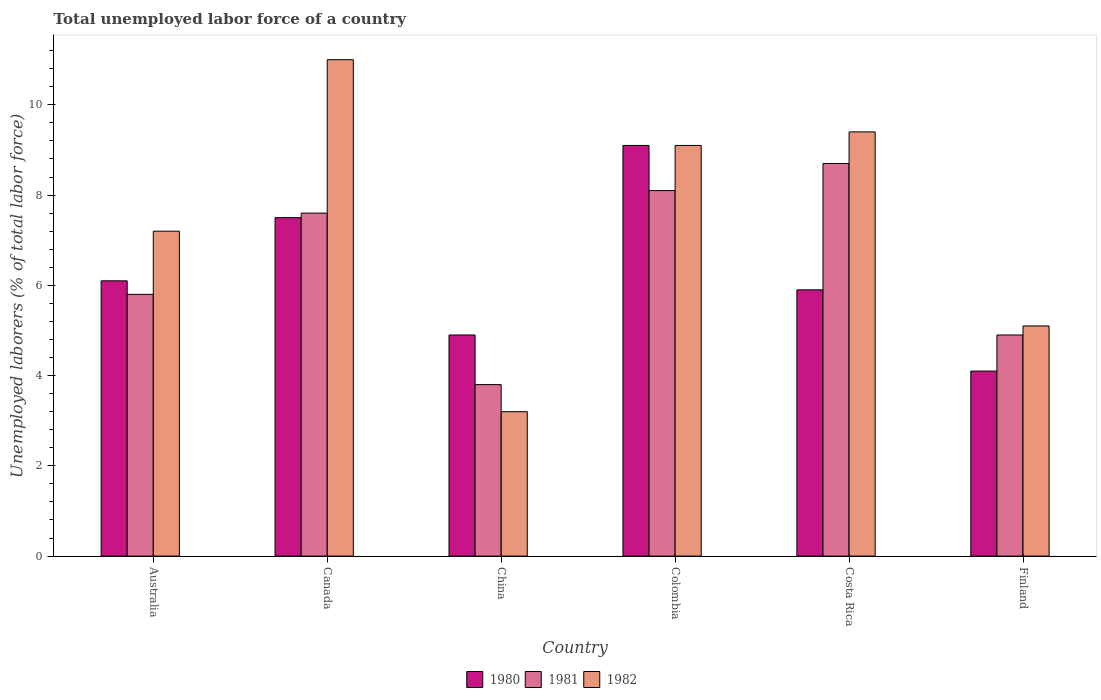How many different coloured bars are there?
Ensure brevity in your answer.  3. How many groups of bars are there?
Your answer should be compact. 6. Are the number of bars on each tick of the X-axis equal?
Provide a succinct answer. Yes. How many bars are there on the 2nd tick from the left?
Offer a terse response. 3. In how many cases, is the number of bars for a given country not equal to the number of legend labels?
Make the answer very short. 0. What is the total unemployed labor force in 1981 in Australia?
Give a very brief answer. 5.8. Across all countries, what is the maximum total unemployed labor force in 1980?
Your answer should be compact. 9.1. Across all countries, what is the minimum total unemployed labor force in 1981?
Your answer should be compact. 3.8. What is the total total unemployed labor force in 1980 in the graph?
Your answer should be very brief. 37.6. What is the difference between the total unemployed labor force in 1980 in China and that in Finland?
Your answer should be compact. 0.8. What is the difference between the total unemployed labor force in 1982 in Colombia and the total unemployed labor force in 1981 in China?
Give a very brief answer. 5.3. What is the average total unemployed labor force in 1980 per country?
Offer a very short reply. 6.27. In how many countries, is the total unemployed labor force in 1981 greater than 2.4 %?
Keep it short and to the point. 6. What is the ratio of the total unemployed labor force in 1980 in Canada to that in Colombia?
Make the answer very short. 0.82. Is the total unemployed labor force in 1980 in China less than that in Colombia?
Offer a very short reply. Yes. What is the difference between the highest and the second highest total unemployed labor force in 1981?
Ensure brevity in your answer.  0.6. What is the difference between the highest and the lowest total unemployed labor force in 1982?
Ensure brevity in your answer.  7.8. In how many countries, is the total unemployed labor force in 1982 greater than the average total unemployed labor force in 1982 taken over all countries?
Your response must be concise. 3. Is it the case that in every country, the sum of the total unemployed labor force in 1981 and total unemployed labor force in 1982 is greater than the total unemployed labor force in 1980?
Keep it short and to the point. Yes. How many countries are there in the graph?
Give a very brief answer. 6. Are the values on the major ticks of Y-axis written in scientific E-notation?
Your response must be concise. No. Does the graph contain grids?
Your answer should be very brief. No. What is the title of the graph?
Give a very brief answer. Total unemployed labor force of a country. What is the label or title of the Y-axis?
Provide a succinct answer. Unemployed laborers (% of total labor force). What is the Unemployed laborers (% of total labor force) of 1980 in Australia?
Your answer should be very brief. 6.1. What is the Unemployed laborers (% of total labor force) in 1981 in Australia?
Make the answer very short. 5.8. What is the Unemployed laborers (% of total labor force) in 1982 in Australia?
Your answer should be very brief. 7.2. What is the Unemployed laborers (% of total labor force) in 1981 in Canada?
Offer a very short reply. 7.6. What is the Unemployed laborers (% of total labor force) of 1982 in Canada?
Give a very brief answer. 11. What is the Unemployed laborers (% of total labor force) of 1980 in China?
Provide a succinct answer. 4.9. What is the Unemployed laborers (% of total labor force) of 1981 in China?
Your response must be concise. 3.8. What is the Unemployed laborers (% of total labor force) in 1982 in China?
Provide a succinct answer. 3.2. What is the Unemployed laborers (% of total labor force) of 1980 in Colombia?
Your answer should be very brief. 9.1. What is the Unemployed laborers (% of total labor force) of 1981 in Colombia?
Offer a very short reply. 8.1. What is the Unemployed laborers (% of total labor force) of 1982 in Colombia?
Provide a short and direct response. 9.1. What is the Unemployed laborers (% of total labor force) in 1980 in Costa Rica?
Provide a short and direct response. 5.9. What is the Unemployed laborers (% of total labor force) of 1981 in Costa Rica?
Your answer should be very brief. 8.7. What is the Unemployed laborers (% of total labor force) in 1982 in Costa Rica?
Your response must be concise. 9.4. What is the Unemployed laborers (% of total labor force) in 1980 in Finland?
Give a very brief answer. 4.1. What is the Unemployed laborers (% of total labor force) of 1981 in Finland?
Your answer should be very brief. 4.9. What is the Unemployed laborers (% of total labor force) of 1982 in Finland?
Make the answer very short. 5.1. Across all countries, what is the maximum Unemployed laborers (% of total labor force) in 1980?
Offer a terse response. 9.1. Across all countries, what is the maximum Unemployed laborers (% of total labor force) in 1981?
Your answer should be compact. 8.7. Across all countries, what is the minimum Unemployed laborers (% of total labor force) in 1980?
Make the answer very short. 4.1. Across all countries, what is the minimum Unemployed laborers (% of total labor force) in 1981?
Keep it short and to the point. 3.8. Across all countries, what is the minimum Unemployed laborers (% of total labor force) of 1982?
Your answer should be compact. 3.2. What is the total Unemployed laborers (% of total labor force) of 1980 in the graph?
Ensure brevity in your answer.  37.6. What is the total Unemployed laborers (% of total labor force) in 1981 in the graph?
Keep it short and to the point. 38.9. What is the difference between the Unemployed laborers (% of total labor force) in 1981 in Australia and that in Canada?
Offer a very short reply. -1.8. What is the difference between the Unemployed laborers (% of total labor force) in 1982 in Australia and that in Canada?
Offer a terse response. -3.8. What is the difference between the Unemployed laborers (% of total labor force) of 1980 in Australia and that in China?
Offer a terse response. 1.2. What is the difference between the Unemployed laborers (% of total labor force) of 1980 in Australia and that in Colombia?
Make the answer very short. -3. What is the difference between the Unemployed laborers (% of total labor force) in 1980 in Australia and that in Costa Rica?
Your response must be concise. 0.2. What is the difference between the Unemployed laborers (% of total labor force) of 1980 in Australia and that in Finland?
Offer a very short reply. 2. What is the difference between the Unemployed laborers (% of total labor force) of 1980 in Canada and that in China?
Keep it short and to the point. 2.6. What is the difference between the Unemployed laborers (% of total labor force) in 1980 in Canada and that in Colombia?
Provide a short and direct response. -1.6. What is the difference between the Unemployed laborers (% of total labor force) in 1981 in Canada and that in Colombia?
Your answer should be very brief. -0.5. What is the difference between the Unemployed laborers (% of total labor force) of 1982 in Canada and that in Colombia?
Give a very brief answer. 1.9. What is the difference between the Unemployed laborers (% of total labor force) of 1981 in Canada and that in Costa Rica?
Your response must be concise. -1.1. What is the difference between the Unemployed laborers (% of total labor force) in 1980 in Canada and that in Finland?
Offer a terse response. 3.4. What is the difference between the Unemployed laborers (% of total labor force) in 1981 in Canada and that in Finland?
Ensure brevity in your answer.  2.7. What is the difference between the Unemployed laborers (% of total labor force) in 1982 in Canada and that in Finland?
Your answer should be very brief. 5.9. What is the difference between the Unemployed laborers (% of total labor force) in 1981 in China and that in Colombia?
Give a very brief answer. -4.3. What is the difference between the Unemployed laborers (% of total labor force) in 1980 in China and that in Costa Rica?
Offer a very short reply. -1. What is the difference between the Unemployed laborers (% of total labor force) of 1981 in China and that in Costa Rica?
Give a very brief answer. -4.9. What is the difference between the Unemployed laborers (% of total labor force) of 1982 in China and that in Costa Rica?
Your answer should be compact. -6.2. What is the difference between the Unemployed laborers (% of total labor force) in 1980 in Colombia and that in Costa Rica?
Provide a succinct answer. 3.2. What is the difference between the Unemployed laborers (% of total labor force) in 1981 in Colombia and that in Costa Rica?
Provide a succinct answer. -0.6. What is the difference between the Unemployed laborers (% of total labor force) of 1980 in Colombia and that in Finland?
Your response must be concise. 5. What is the difference between the Unemployed laborers (% of total labor force) of 1982 in Colombia and that in Finland?
Ensure brevity in your answer.  4. What is the difference between the Unemployed laborers (% of total labor force) in 1980 in Costa Rica and that in Finland?
Your answer should be very brief. 1.8. What is the difference between the Unemployed laborers (% of total labor force) of 1982 in Costa Rica and that in Finland?
Offer a very short reply. 4.3. What is the difference between the Unemployed laborers (% of total labor force) of 1980 in Australia and the Unemployed laborers (% of total labor force) of 1982 in Canada?
Give a very brief answer. -4.9. What is the difference between the Unemployed laborers (% of total labor force) in 1980 in Australia and the Unemployed laborers (% of total labor force) in 1981 in China?
Ensure brevity in your answer.  2.3. What is the difference between the Unemployed laborers (% of total labor force) of 1980 in Australia and the Unemployed laborers (% of total labor force) of 1982 in China?
Offer a terse response. 2.9. What is the difference between the Unemployed laborers (% of total labor force) of 1981 in Australia and the Unemployed laborers (% of total labor force) of 1982 in China?
Your answer should be compact. 2.6. What is the difference between the Unemployed laborers (% of total labor force) of 1980 in Australia and the Unemployed laborers (% of total labor force) of 1981 in Costa Rica?
Make the answer very short. -2.6. What is the difference between the Unemployed laborers (% of total labor force) of 1980 in Australia and the Unemployed laborers (% of total labor force) of 1981 in Finland?
Give a very brief answer. 1.2. What is the difference between the Unemployed laborers (% of total labor force) in 1980 in Australia and the Unemployed laborers (% of total labor force) in 1982 in Finland?
Keep it short and to the point. 1. What is the difference between the Unemployed laborers (% of total labor force) in 1981 in Australia and the Unemployed laborers (% of total labor force) in 1982 in Finland?
Ensure brevity in your answer.  0.7. What is the difference between the Unemployed laborers (% of total labor force) in 1980 in Canada and the Unemployed laborers (% of total labor force) in 1981 in China?
Offer a terse response. 3.7. What is the difference between the Unemployed laborers (% of total labor force) in 1980 in Canada and the Unemployed laborers (% of total labor force) in 1982 in China?
Provide a succinct answer. 4.3. What is the difference between the Unemployed laborers (% of total labor force) in 1980 in Canada and the Unemployed laborers (% of total labor force) in 1981 in Colombia?
Keep it short and to the point. -0.6. What is the difference between the Unemployed laborers (% of total labor force) of 1980 in Canada and the Unemployed laborers (% of total labor force) of 1982 in Colombia?
Your answer should be compact. -1.6. What is the difference between the Unemployed laborers (% of total labor force) of 1980 in Canada and the Unemployed laborers (% of total labor force) of 1982 in Costa Rica?
Make the answer very short. -1.9. What is the difference between the Unemployed laborers (% of total labor force) of 1980 in Canada and the Unemployed laborers (% of total labor force) of 1982 in Finland?
Provide a succinct answer. 2.4. What is the difference between the Unemployed laborers (% of total labor force) in 1980 in China and the Unemployed laborers (% of total labor force) in 1981 in Colombia?
Your answer should be very brief. -3.2. What is the difference between the Unemployed laborers (% of total labor force) in 1980 in China and the Unemployed laborers (% of total labor force) in 1982 in Colombia?
Your response must be concise. -4.2. What is the difference between the Unemployed laborers (% of total labor force) of 1981 in China and the Unemployed laborers (% of total labor force) of 1982 in Colombia?
Your answer should be compact. -5.3. What is the difference between the Unemployed laborers (% of total labor force) in 1980 in China and the Unemployed laborers (% of total labor force) in 1981 in Costa Rica?
Your answer should be very brief. -3.8. What is the difference between the Unemployed laborers (% of total labor force) of 1980 in China and the Unemployed laborers (% of total labor force) of 1982 in Costa Rica?
Your answer should be very brief. -4.5. What is the difference between the Unemployed laborers (% of total labor force) of 1980 in China and the Unemployed laborers (% of total labor force) of 1982 in Finland?
Keep it short and to the point. -0.2. What is the difference between the Unemployed laborers (% of total labor force) in 1980 in Colombia and the Unemployed laborers (% of total labor force) in 1981 in Costa Rica?
Your answer should be very brief. 0.4. What is the difference between the Unemployed laborers (% of total labor force) of 1980 in Colombia and the Unemployed laborers (% of total labor force) of 1982 in Costa Rica?
Your response must be concise. -0.3. What is the difference between the Unemployed laborers (% of total labor force) in 1981 in Colombia and the Unemployed laborers (% of total labor force) in 1982 in Finland?
Make the answer very short. 3. What is the difference between the Unemployed laborers (% of total labor force) of 1980 in Costa Rica and the Unemployed laborers (% of total labor force) of 1982 in Finland?
Your answer should be compact. 0.8. What is the difference between the Unemployed laborers (% of total labor force) in 1981 in Costa Rica and the Unemployed laborers (% of total labor force) in 1982 in Finland?
Make the answer very short. 3.6. What is the average Unemployed laborers (% of total labor force) in 1980 per country?
Make the answer very short. 6.27. What is the average Unemployed laborers (% of total labor force) of 1981 per country?
Your answer should be very brief. 6.48. What is the difference between the Unemployed laborers (% of total labor force) of 1981 and Unemployed laborers (% of total labor force) of 1982 in Canada?
Offer a terse response. -3.4. What is the difference between the Unemployed laborers (% of total labor force) in 1980 and Unemployed laborers (% of total labor force) in 1981 in China?
Offer a terse response. 1.1. What is the difference between the Unemployed laborers (% of total labor force) of 1980 and Unemployed laborers (% of total labor force) of 1982 in China?
Ensure brevity in your answer.  1.7. What is the difference between the Unemployed laborers (% of total labor force) of 1981 and Unemployed laborers (% of total labor force) of 1982 in China?
Your answer should be very brief. 0.6. What is the difference between the Unemployed laborers (% of total labor force) of 1980 and Unemployed laborers (% of total labor force) of 1981 in Finland?
Ensure brevity in your answer.  -0.8. What is the difference between the Unemployed laborers (% of total labor force) of 1980 and Unemployed laborers (% of total labor force) of 1982 in Finland?
Keep it short and to the point. -1. What is the difference between the Unemployed laborers (% of total labor force) in 1981 and Unemployed laborers (% of total labor force) in 1982 in Finland?
Offer a very short reply. -0.2. What is the ratio of the Unemployed laborers (% of total labor force) of 1980 in Australia to that in Canada?
Offer a very short reply. 0.81. What is the ratio of the Unemployed laborers (% of total labor force) in 1981 in Australia to that in Canada?
Your answer should be compact. 0.76. What is the ratio of the Unemployed laborers (% of total labor force) in 1982 in Australia to that in Canada?
Provide a succinct answer. 0.65. What is the ratio of the Unemployed laborers (% of total labor force) in 1980 in Australia to that in China?
Provide a short and direct response. 1.24. What is the ratio of the Unemployed laborers (% of total labor force) of 1981 in Australia to that in China?
Keep it short and to the point. 1.53. What is the ratio of the Unemployed laborers (% of total labor force) in 1982 in Australia to that in China?
Your response must be concise. 2.25. What is the ratio of the Unemployed laborers (% of total labor force) of 1980 in Australia to that in Colombia?
Your answer should be compact. 0.67. What is the ratio of the Unemployed laborers (% of total labor force) of 1981 in Australia to that in Colombia?
Provide a succinct answer. 0.72. What is the ratio of the Unemployed laborers (% of total labor force) of 1982 in Australia to that in Colombia?
Give a very brief answer. 0.79. What is the ratio of the Unemployed laborers (% of total labor force) in 1980 in Australia to that in Costa Rica?
Offer a terse response. 1.03. What is the ratio of the Unemployed laborers (% of total labor force) in 1981 in Australia to that in Costa Rica?
Offer a very short reply. 0.67. What is the ratio of the Unemployed laborers (% of total labor force) of 1982 in Australia to that in Costa Rica?
Give a very brief answer. 0.77. What is the ratio of the Unemployed laborers (% of total labor force) of 1980 in Australia to that in Finland?
Keep it short and to the point. 1.49. What is the ratio of the Unemployed laborers (% of total labor force) in 1981 in Australia to that in Finland?
Ensure brevity in your answer.  1.18. What is the ratio of the Unemployed laborers (% of total labor force) in 1982 in Australia to that in Finland?
Offer a terse response. 1.41. What is the ratio of the Unemployed laborers (% of total labor force) of 1980 in Canada to that in China?
Ensure brevity in your answer.  1.53. What is the ratio of the Unemployed laborers (% of total labor force) in 1982 in Canada to that in China?
Your response must be concise. 3.44. What is the ratio of the Unemployed laborers (% of total labor force) of 1980 in Canada to that in Colombia?
Offer a terse response. 0.82. What is the ratio of the Unemployed laborers (% of total labor force) in 1981 in Canada to that in Colombia?
Give a very brief answer. 0.94. What is the ratio of the Unemployed laborers (% of total labor force) in 1982 in Canada to that in Colombia?
Your response must be concise. 1.21. What is the ratio of the Unemployed laborers (% of total labor force) of 1980 in Canada to that in Costa Rica?
Make the answer very short. 1.27. What is the ratio of the Unemployed laborers (% of total labor force) of 1981 in Canada to that in Costa Rica?
Keep it short and to the point. 0.87. What is the ratio of the Unemployed laborers (% of total labor force) in 1982 in Canada to that in Costa Rica?
Give a very brief answer. 1.17. What is the ratio of the Unemployed laborers (% of total labor force) of 1980 in Canada to that in Finland?
Your answer should be very brief. 1.83. What is the ratio of the Unemployed laborers (% of total labor force) of 1981 in Canada to that in Finland?
Make the answer very short. 1.55. What is the ratio of the Unemployed laborers (% of total labor force) of 1982 in Canada to that in Finland?
Offer a terse response. 2.16. What is the ratio of the Unemployed laborers (% of total labor force) of 1980 in China to that in Colombia?
Ensure brevity in your answer.  0.54. What is the ratio of the Unemployed laborers (% of total labor force) of 1981 in China to that in Colombia?
Make the answer very short. 0.47. What is the ratio of the Unemployed laborers (% of total labor force) in 1982 in China to that in Colombia?
Offer a very short reply. 0.35. What is the ratio of the Unemployed laborers (% of total labor force) in 1980 in China to that in Costa Rica?
Your response must be concise. 0.83. What is the ratio of the Unemployed laborers (% of total labor force) of 1981 in China to that in Costa Rica?
Ensure brevity in your answer.  0.44. What is the ratio of the Unemployed laborers (% of total labor force) in 1982 in China to that in Costa Rica?
Make the answer very short. 0.34. What is the ratio of the Unemployed laborers (% of total labor force) of 1980 in China to that in Finland?
Offer a very short reply. 1.2. What is the ratio of the Unemployed laborers (% of total labor force) in 1981 in China to that in Finland?
Ensure brevity in your answer.  0.78. What is the ratio of the Unemployed laborers (% of total labor force) in 1982 in China to that in Finland?
Your answer should be compact. 0.63. What is the ratio of the Unemployed laborers (% of total labor force) in 1980 in Colombia to that in Costa Rica?
Ensure brevity in your answer.  1.54. What is the ratio of the Unemployed laborers (% of total labor force) in 1982 in Colombia to that in Costa Rica?
Provide a succinct answer. 0.97. What is the ratio of the Unemployed laborers (% of total labor force) in 1980 in Colombia to that in Finland?
Make the answer very short. 2.22. What is the ratio of the Unemployed laborers (% of total labor force) of 1981 in Colombia to that in Finland?
Your answer should be compact. 1.65. What is the ratio of the Unemployed laborers (% of total labor force) in 1982 in Colombia to that in Finland?
Your answer should be compact. 1.78. What is the ratio of the Unemployed laborers (% of total labor force) of 1980 in Costa Rica to that in Finland?
Keep it short and to the point. 1.44. What is the ratio of the Unemployed laborers (% of total labor force) in 1981 in Costa Rica to that in Finland?
Provide a succinct answer. 1.78. What is the ratio of the Unemployed laborers (% of total labor force) in 1982 in Costa Rica to that in Finland?
Keep it short and to the point. 1.84. What is the difference between the highest and the second highest Unemployed laborers (% of total labor force) of 1980?
Provide a short and direct response. 1.6. What is the difference between the highest and the lowest Unemployed laborers (% of total labor force) in 1980?
Offer a terse response. 5. What is the difference between the highest and the lowest Unemployed laborers (% of total labor force) in 1981?
Provide a short and direct response. 4.9. What is the difference between the highest and the lowest Unemployed laborers (% of total labor force) of 1982?
Your response must be concise. 7.8. 